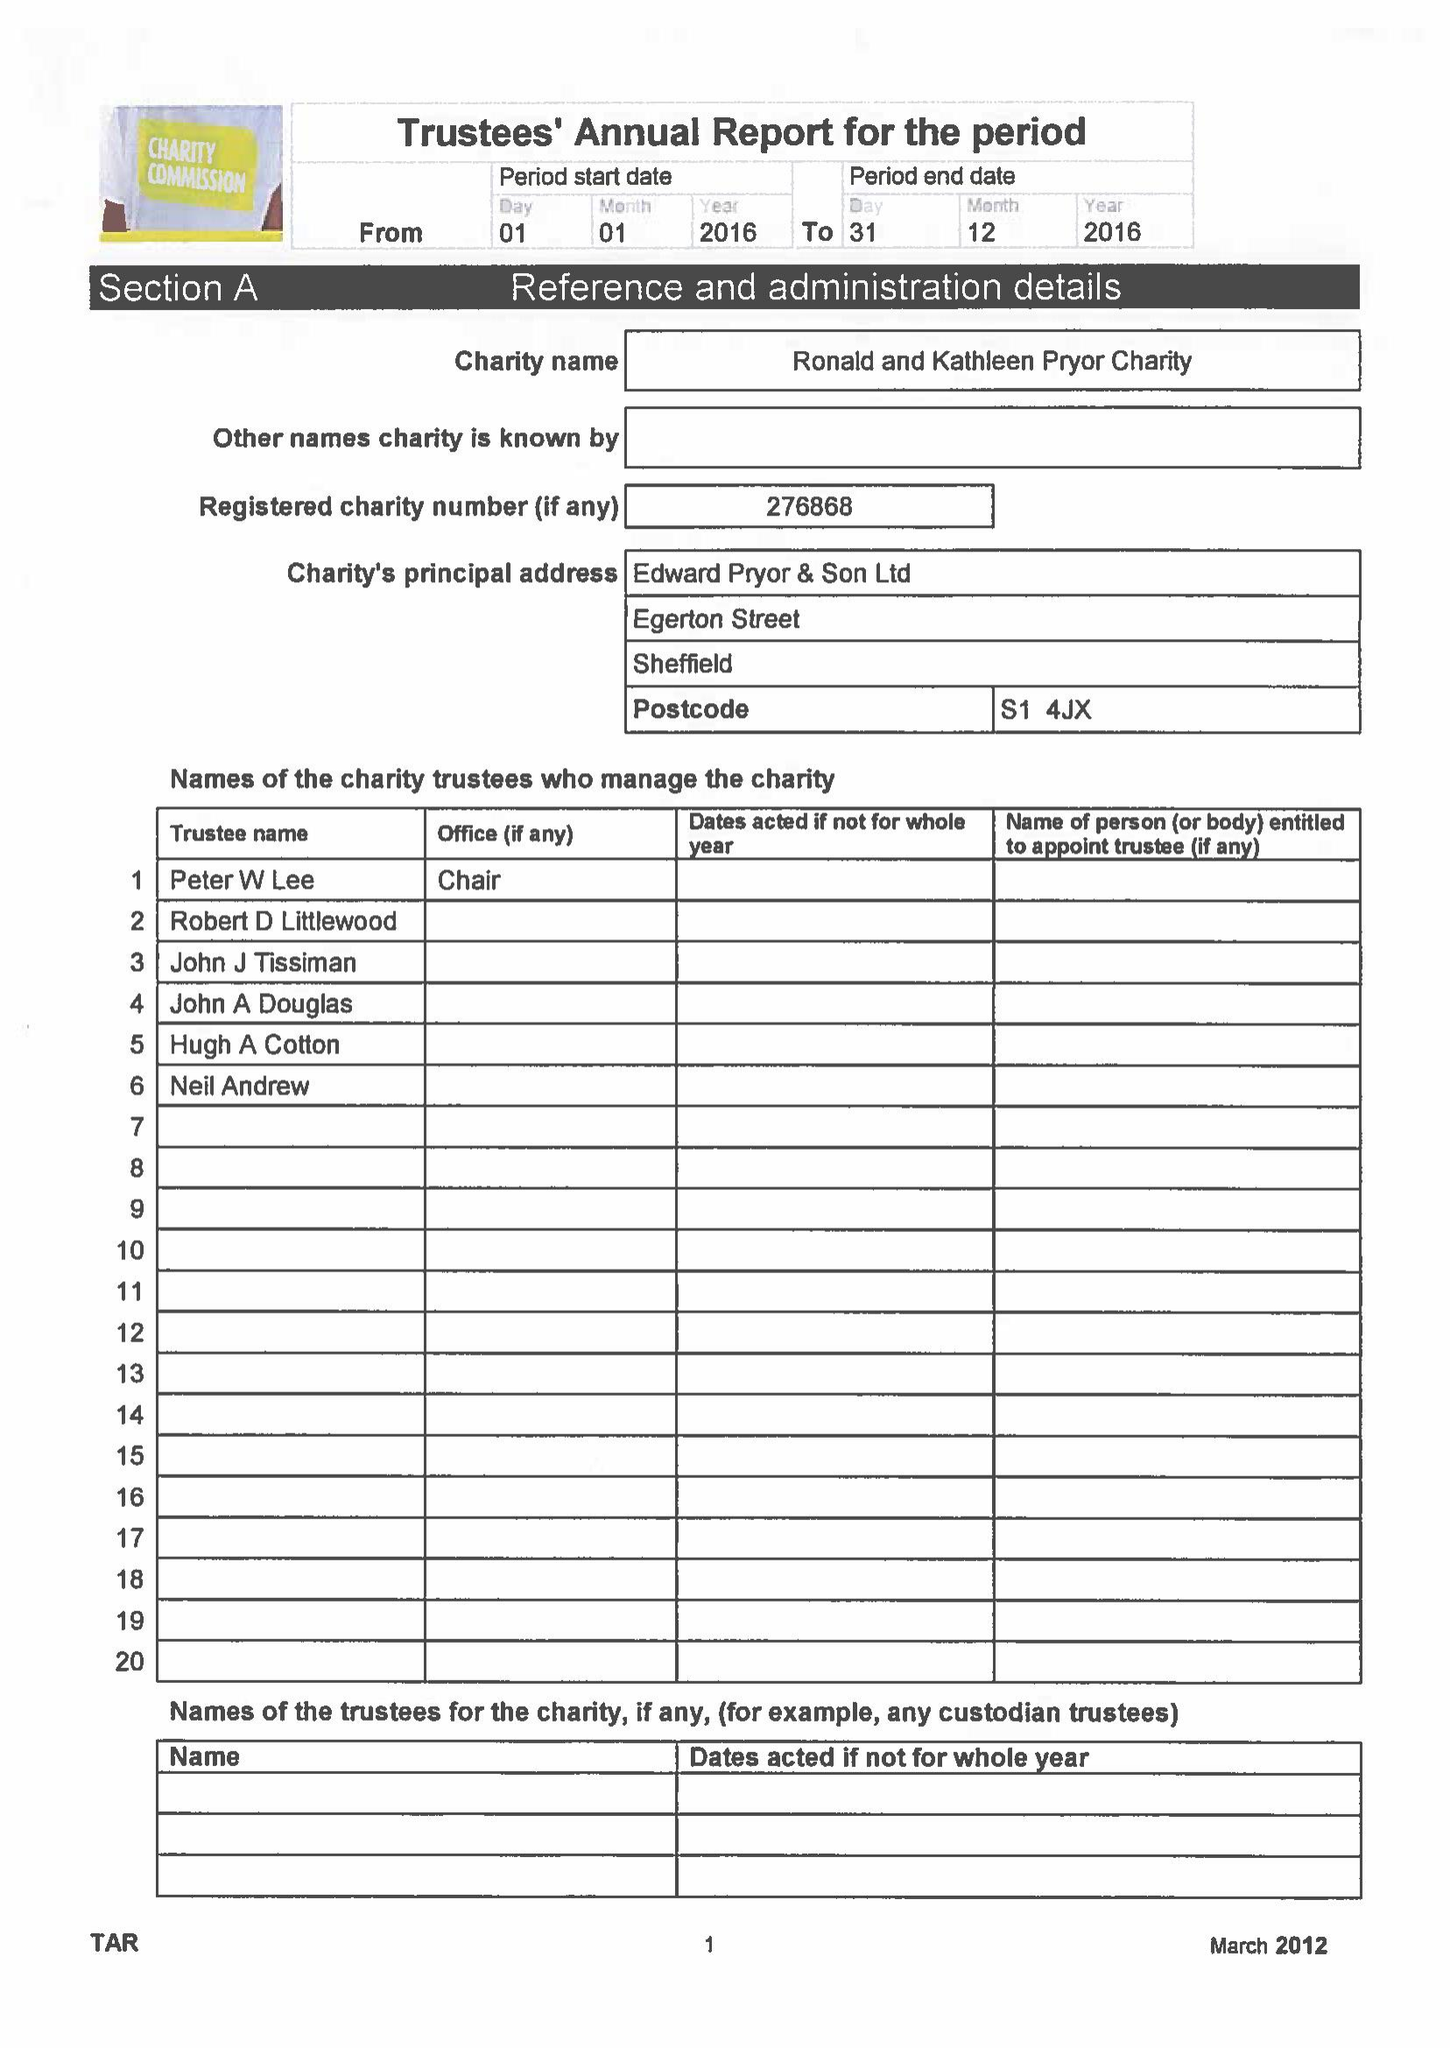What is the value for the income_annually_in_british_pounds?
Answer the question using a single word or phrase. 31681.00 